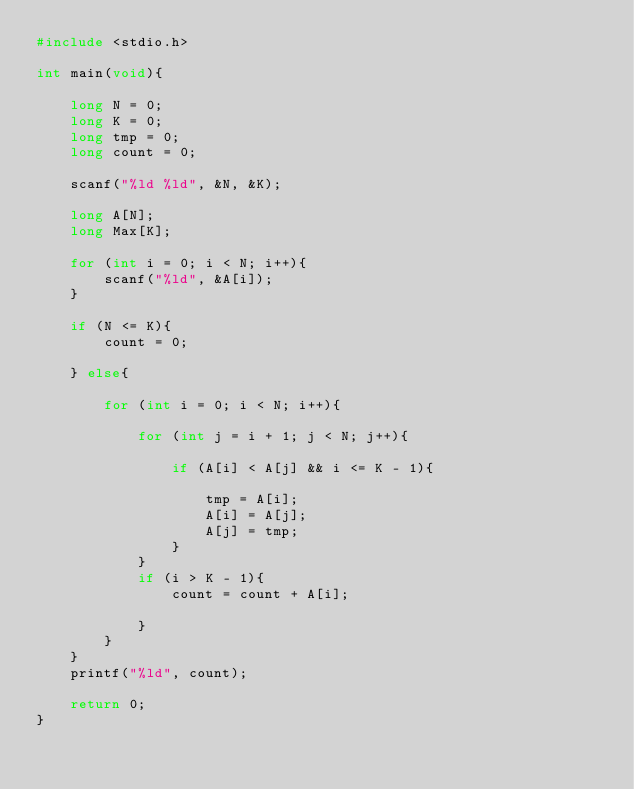<code> <loc_0><loc_0><loc_500><loc_500><_C_>#include <stdio.h>

int main(void){

    long N = 0;
    long K = 0;
    long tmp = 0;
    long count = 0;

    scanf("%ld %ld", &N, &K);

    long A[N];
    long Max[K];

    for (int i = 0; i < N; i++){
        scanf("%ld", &A[i]);
    }

    if (N <= K){
        count = 0;

    } else{

        for (int i = 0; i < N; i++){

            for (int j = i + 1; j < N; j++){

                if (A[i] < A[j] && i <= K - 1){

                    tmp = A[i];
                    A[i] = A[j];
                    A[j] = tmp;
                }
            }
            if (i > K - 1){
                count = count + A[i];

            }
        }
    }
    printf("%ld", count);

    return 0;
}</code> 